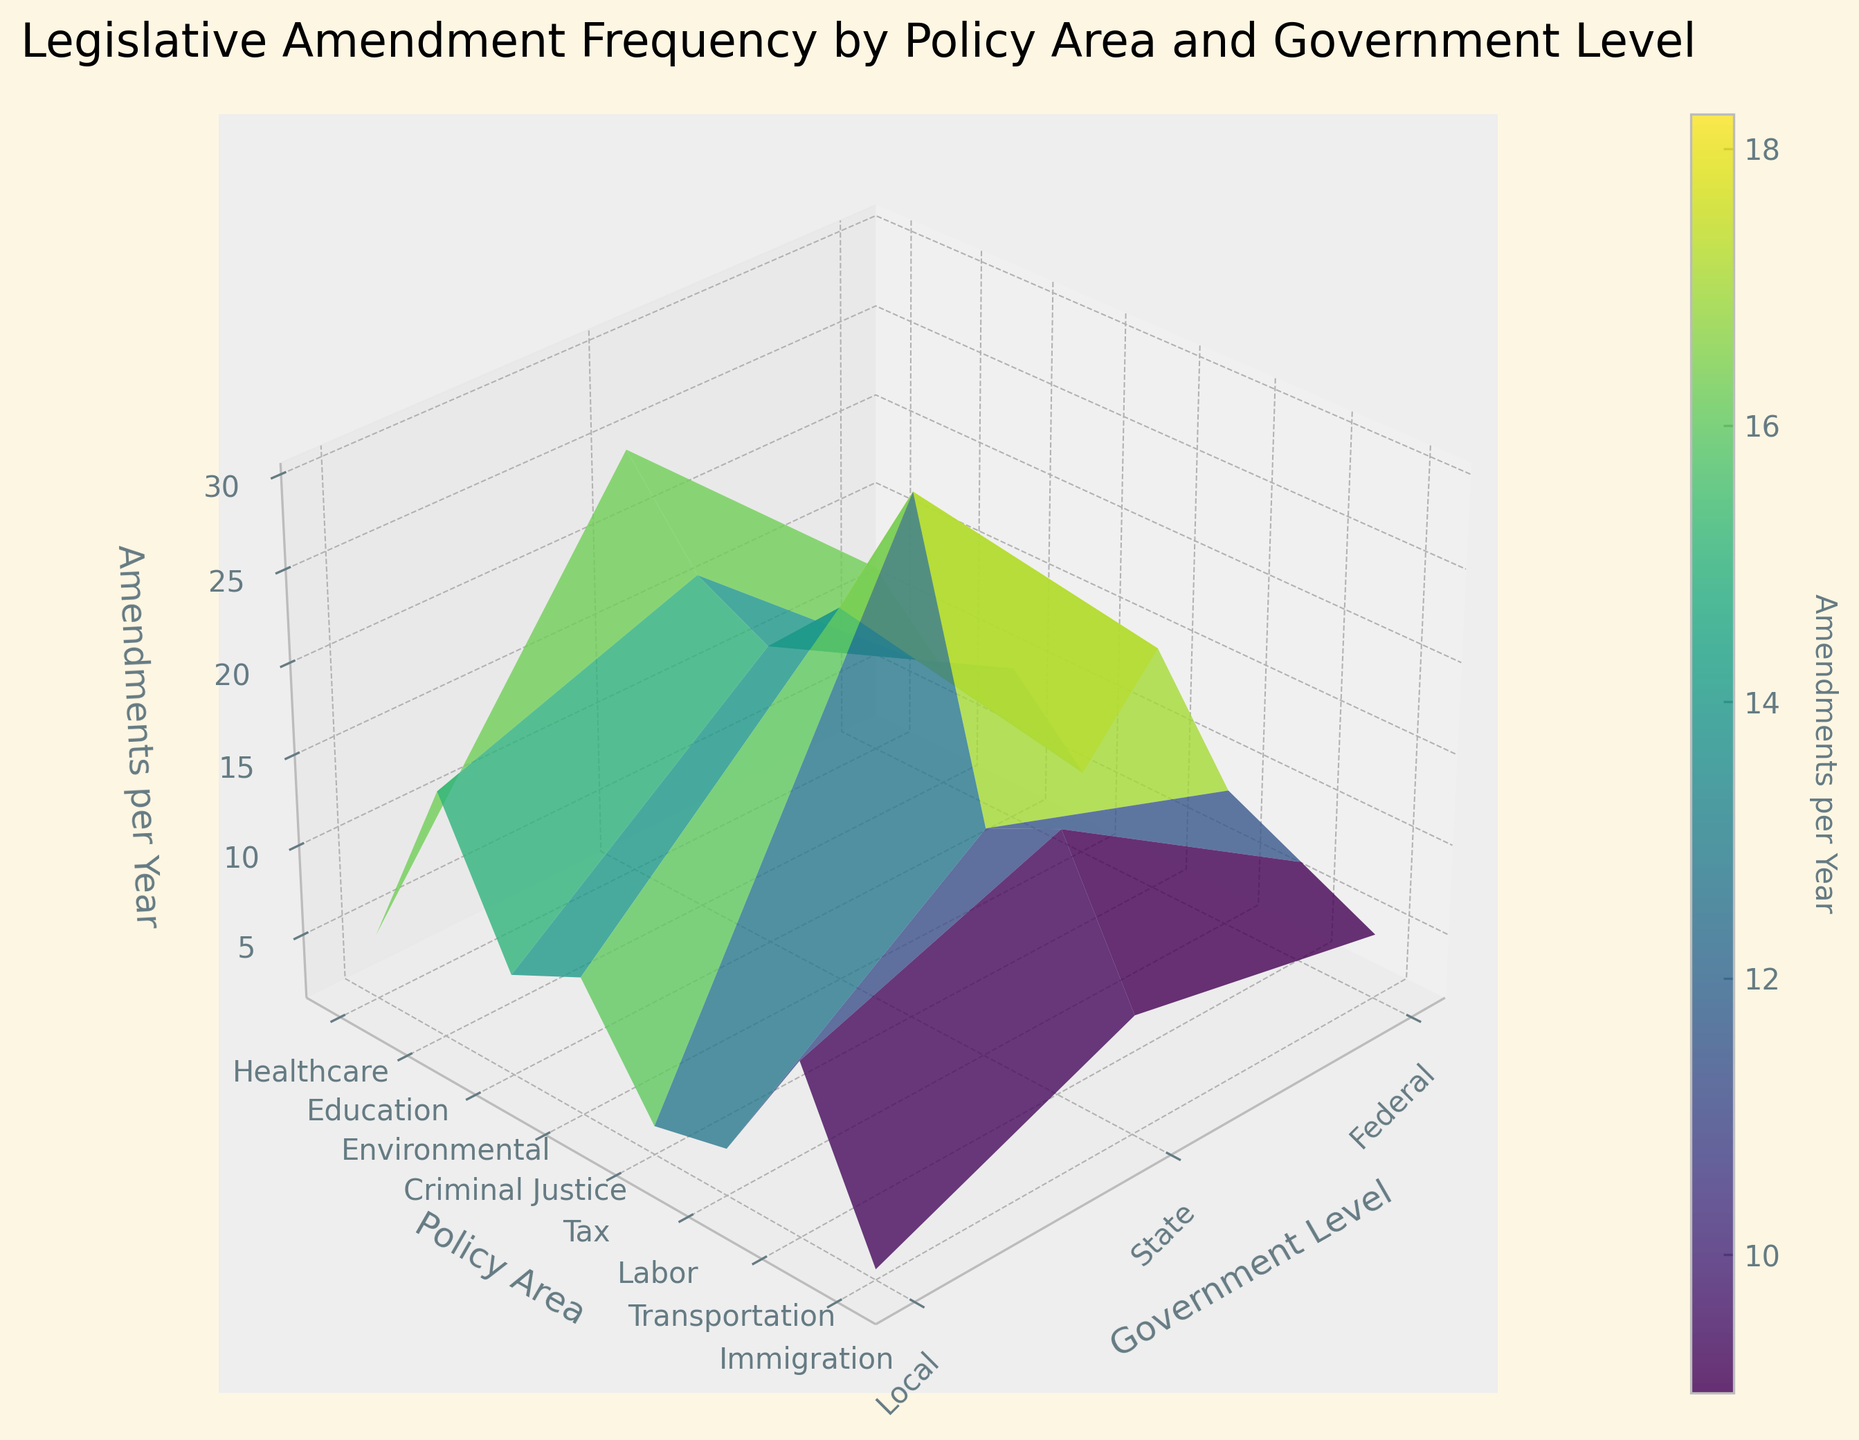What's the title of the figure? The title is typically positioned at the top of the figure. In this case, it's explicitly shown as "Legislative Amendment Frequency by Policy Area and Government Level".
Answer: Legislative Amendment Frequency by Policy Area and Government Level What do the colors represent in the figure? In surface plots, colors usually indicate different levels of the z-axis variable. Here, the color indicates the number of amendments per year, as specified by the color bar on the right.
Answer: Number of Amendments per Year Which policy area and government level combination has the highest number of amendments per year? To identify this, look for the peak on the surface plot, where the z-axis value is the highest. The peak corresponds to the coordinates "Tax" on the y-axis and "State" on the x-axis.
Answer: Tax at State level What is the range of the 'Amendments per Year' values? Check the color bar and the z-axis labels to find the minimum and maximum values. The plot ranges from the lowest value shown (2) to the highest (30).
Answer: 2 to 30 Which government level has the fewest amendments in the "Immigration" policy area? Find the "Immigration" row in the y-axis, then compare the z-values for "Federal", "State", and "Local" in this row. The lowest z-value here is for the "Local" level.
Answer: Local Compare the number of amendments for "Healthcare" at the "Federal" and "State" levels. Which is higher and by how much? Locate "Healthcare" on the y-axis, then compare the z-values for "Federal" and "State" levels. The values are 12 and 25, respectively. Calculate the difference: 25 - 12 = 13.
Answer: State is higher by 13 What is the average number of amendments per year for the "Education" policy area? Find the "Education" row on the y-axis and average the z-values across "Federal", "State", and "Local" (8, 20, and 15 respectively). (8 + 20 + 15)/3 = 14.33.
Answer: 14.33 Identify which policy area at the "Federal" level has the lowest number of amendments per year. Look at the z-values for the "Federal" level across all policy areas. The lowest value is found in the "Immigration" area.
Answer: Immigration What's the combined number of amendments for the "Labor" and "Transportation" policy areas at the "State" level? Locate “State” on the x-axis and sum the z-values for "Labor" and "Transportation". These are 14 and 16, so 14 + 16 = 30.
Answer: 30 How does the number of amendments for "Criminal Justice" at the "Local" level compare to that at the "Federal" level? Compare the z-values for "Criminal Justice" at "Local" and "Federal". The values are 9 and 6, respectively. 9 is higher than 6 by 3.
Answer: Local is higher by 3 